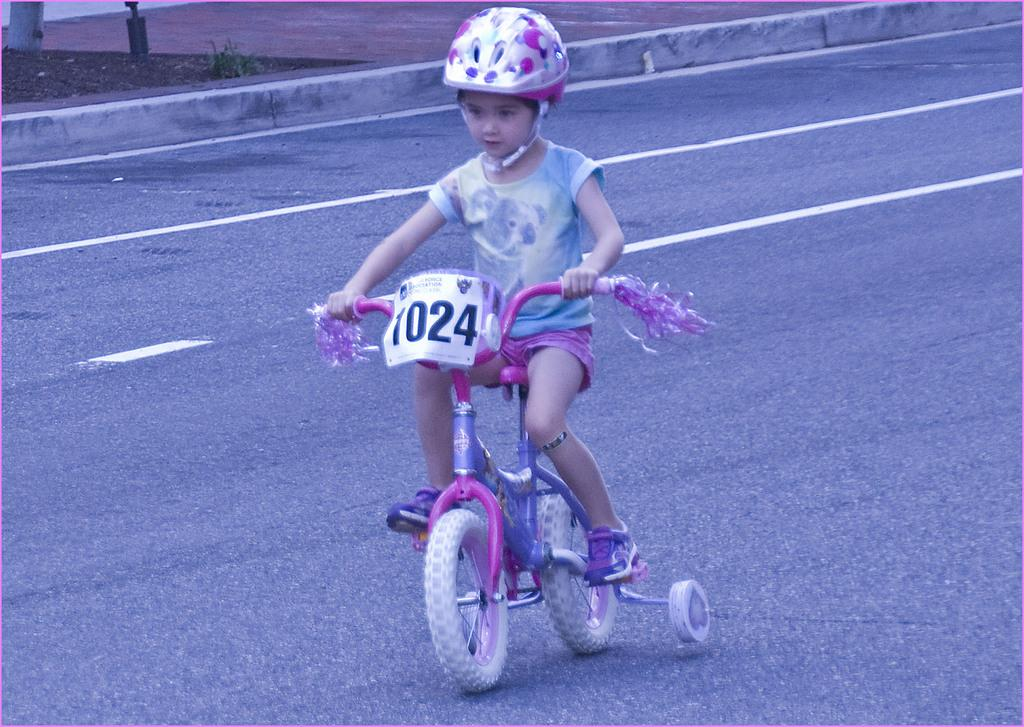Who is the main subject in the image? There is a girl in the image. What is the girl doing in the image? The girl is riding a bicycle. Where is the bicycle located in the image? The bicycle is on the road. How many roses can be seen in the image? There are no roses present in the image. What letters are visible on the girl's shirt in the image? The provided facts do not mention any letters on the girl's shirt, so we cannot answer this question. 